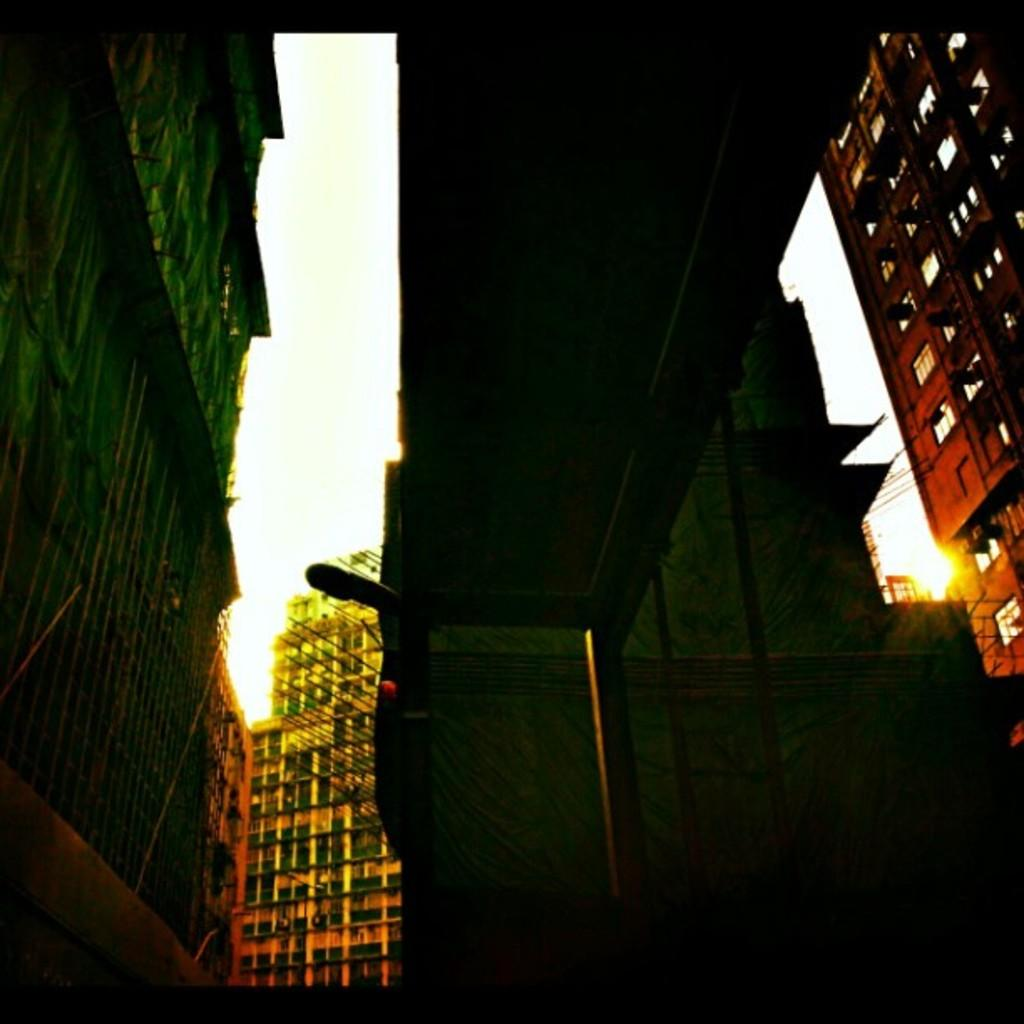What type of structures can be seen in the image? There are buildings with windows in the image. What type of infrastructure is present in the image? There is a flyover in the image. What supports the flyover? The flyover has pillars. Where can the cobweb be found in the image? There is no cobweb present in the image. What type of crops can be seen growing in the field in the image? There is no field present in the image. 